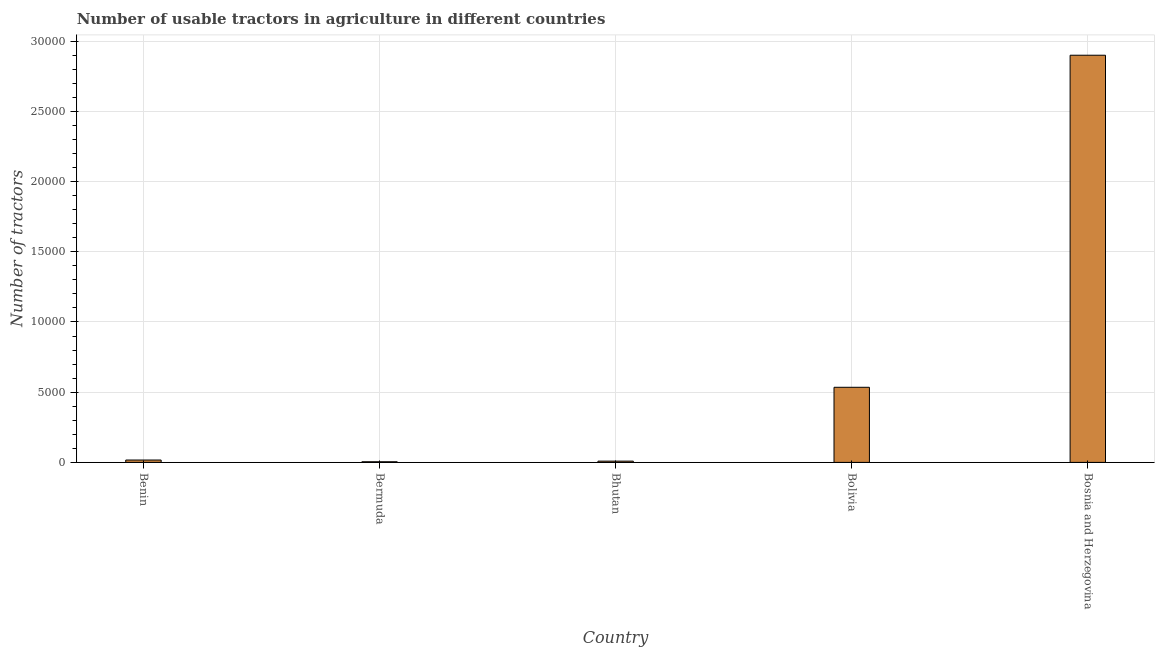Does the graph contain any zero values?
Ensure brevity in your answer.  No. Does the graph contain grids?
Your answer should be very brief. Yes. What is the title of the graph?
Give a very brief answer. Number of usable tractors in agriculture in different countries. What is the label or title of the X-axis?
Your answer should be very brief. Country. What is the label or title of the Y-axis?
Keep it short and to the point. Number of tractors. What is the number of tractors in Bosnia and Herzegovina?
Your answer should be very brief. 2.90e+04. Across all countries, what is the maximum number of tractors?
Ensure brevity in your answer.  2.90e+04. In which country was the number of tractors maximum?
Make the answer very short. Bosnia and Herzegovina. In which country was the number of tractors minimum?
Ensure brevity in your answer.  Bermuda. What is the sum of the number of tractors?
Offer a very short reply. 3.47e+04. What is the difference between the number of tractors in Bermuda and Bhutan?
Your answer should be very brief. -45. What is the average number of tractors per country?
Your response must be concise. 6930. What is the median number of tractors?
Your answer should be compact. 169. In how many countries, is the number of tractors greater than 4000 ?
Give a very brief answer. 2. What is the ratio of the number of tractors in Bolivia to that in Bosnia and Herzegovina?
Give a very brief answer. 0.18. Is the number of tractors in Benin less than that in Bhutan?
Give a very brief answer. No. Is the difference between the number of tractors in Bhutan and Bolivia greater than the difference between any two countries?
Provide a succinct answer. No. What is the difference between the highest and the second highest number of tractors?
Your answer should be compact. 2.36e+04. Is the sum of the number of tractors in Bolivia and Bosnia and Herzegovina greater than the maximum number of tractors across all countries?
Give a very brief answer. Yes. What is the difference between the highest and the lowest number of tractors?
Your answer should be compact. 2.90e+04. How many bars are there?
Your answer should be compact. 5. Are all the bars in the graph horizontal?
Offer a terse response. No. What is the difference between two consecutive major ticks on the Y-axis?
Give a very brief answer. 5000. Are the values on the major ticks of Y-axis written in scientific E-notation?
Offer a very short reply. No. What is the Number of tractors in Benin?
Offer a very short reply. 169. What is the Number of tractors of Bolivia?
Your response must be concise. 5350. What is the Number of tractors of Bosnia and Herzegovina?
Make the answer very short. 2.90e+04. What is the difference between the Number of tractors in Benin and Bermuda?
Your response must be concise. 124. What is the difference between the Number of tractors in Benin and Bhutan?
Offer a very short reply. 79. What is the difference between the Number of tractors in Benin and Bolivia?
Offer a very short reply. -5181. What is the difference between the Number of tractors in Benin and Bosnia and Herzegovina?
Keep it short and to the point. -2.88e+04. What is the difference between the Number of tractors in Bermuda and Bhutan?
Your answer should be very brief. -45. What is the difference between the Number of tractors in Bermuda and Bolivia?
Provide a short and direct response. -5305. What is the difference between the Number of tractors in Bermuda and Bosnia and Herzegovina?
Your answer should be very brief. -2.90e+04. What is the difference between the Number of tractors in Bhutan and Bolivia?
Provide a short and direct response. -5260. What is the difference between the Number of tractors in Bhutan and Bosnia and Herzegovina?
Offer a very short reply. -2.89e+04. What is the difference between the Number of tractors in Bolivia and Bosnia and Herzegovina?
Offer a very short reply. -2.36e+04. What is the ratio of the Number of tractors in Benin to that in Bermuda?
Offer a terse response. 3.76. What is the ratio of the Number of tractors in Benin to that in Bhutan?
Offer a very short reply. 1.88. What is the ratio of the Number of tractors in Benin to that in Bolivia?
Make the answer very short. 0.03. What is the ratio of the Number of tractors in Benin to that in Bosnia and Herzegovina?
Your answer should be very brief. 0.01. What is the ratio of the Number of tractors in Bermuda to that in Bolivia?
Your answer should be compact. 0.01. What is the ratio of the Number of tractors in Bermuda to that in Bosnia and Herzegovina?
Keep it short and to the point. 0. What is the ratio of the Number of tractors in Bhutan to that in Bolivia?
Provide a short and direct response. 0.02. What is the ratio of the Number of tractors in Bhutan to that in Bosnia and Herzegovina?
Provide a succinct answer. 0. What is the ratio of the Number of tractors in Bolivia to that in Bosnia and Herzegovina?
Your answer should be compact. 0.18. 